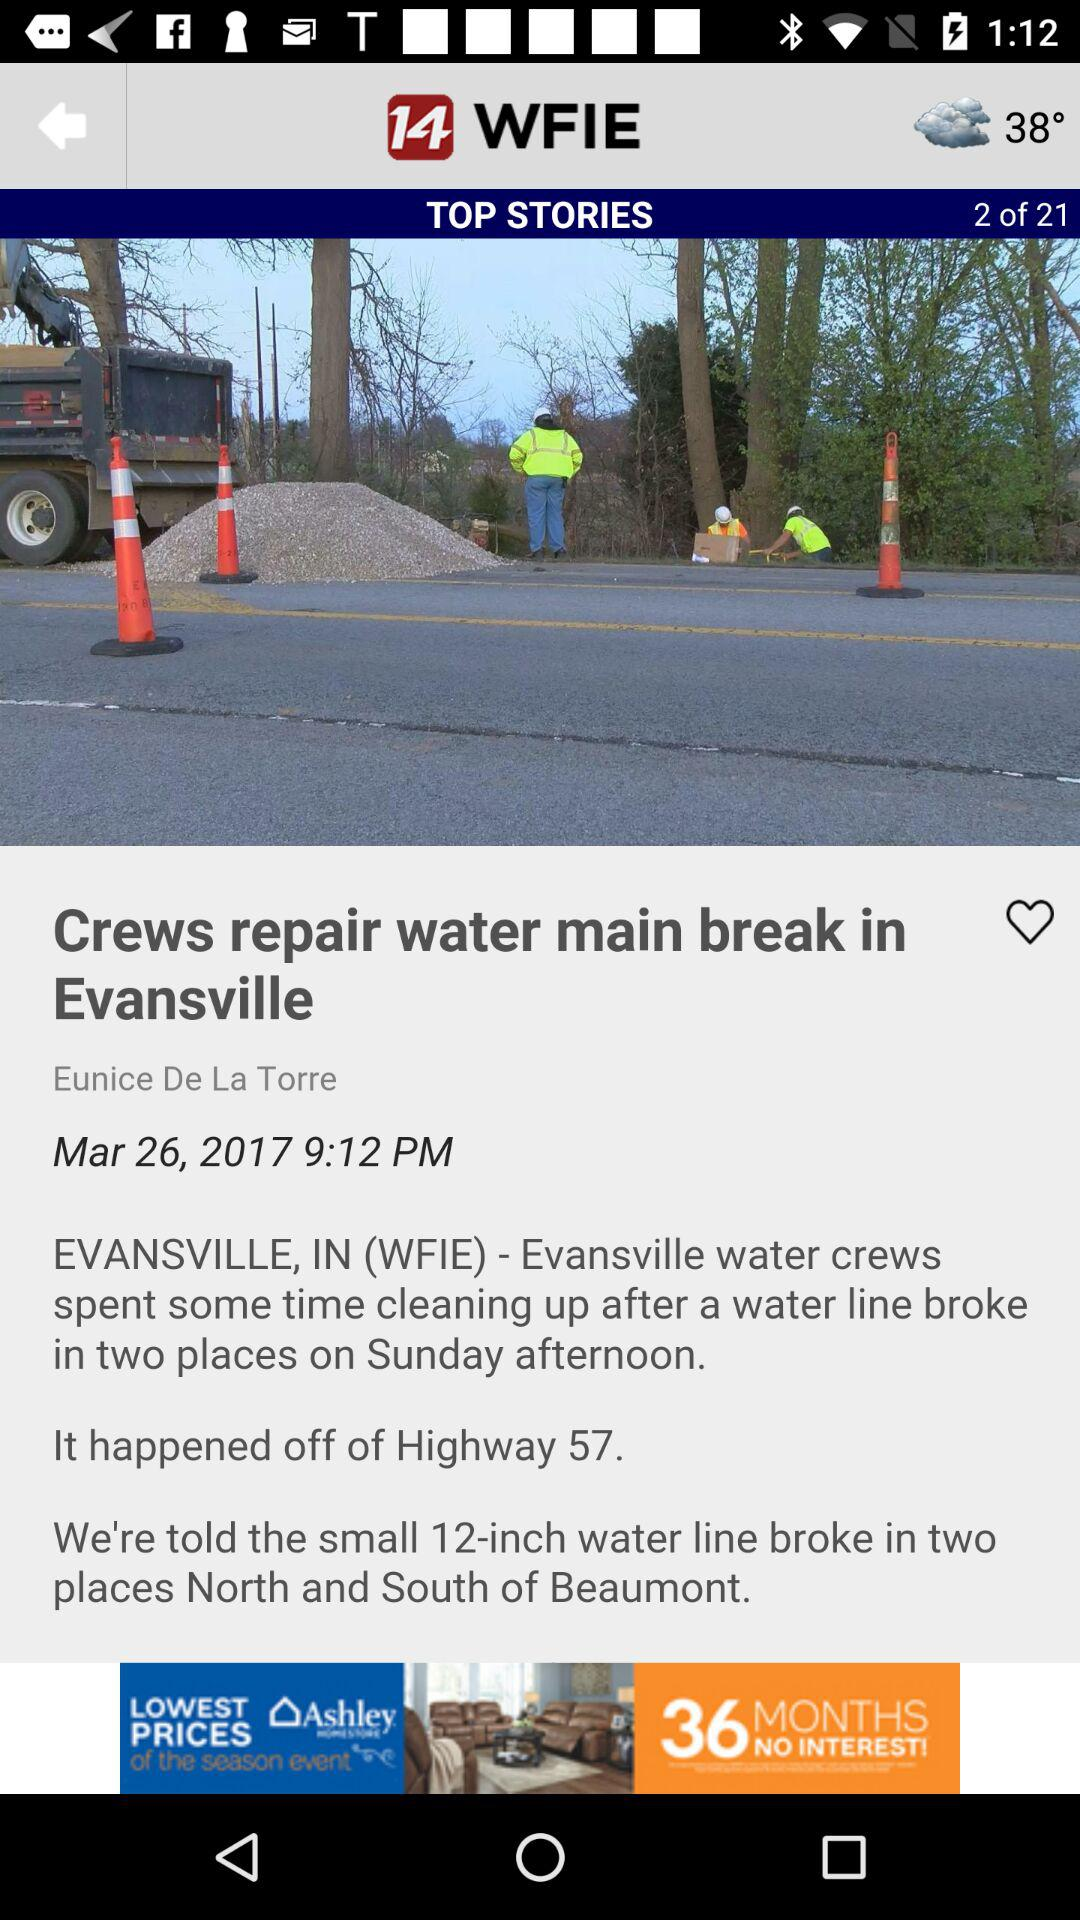On what date was the news "Crews repair water main break in Evansville" posted? The news was posted on March 26, 2017 at 9:12 PM. 